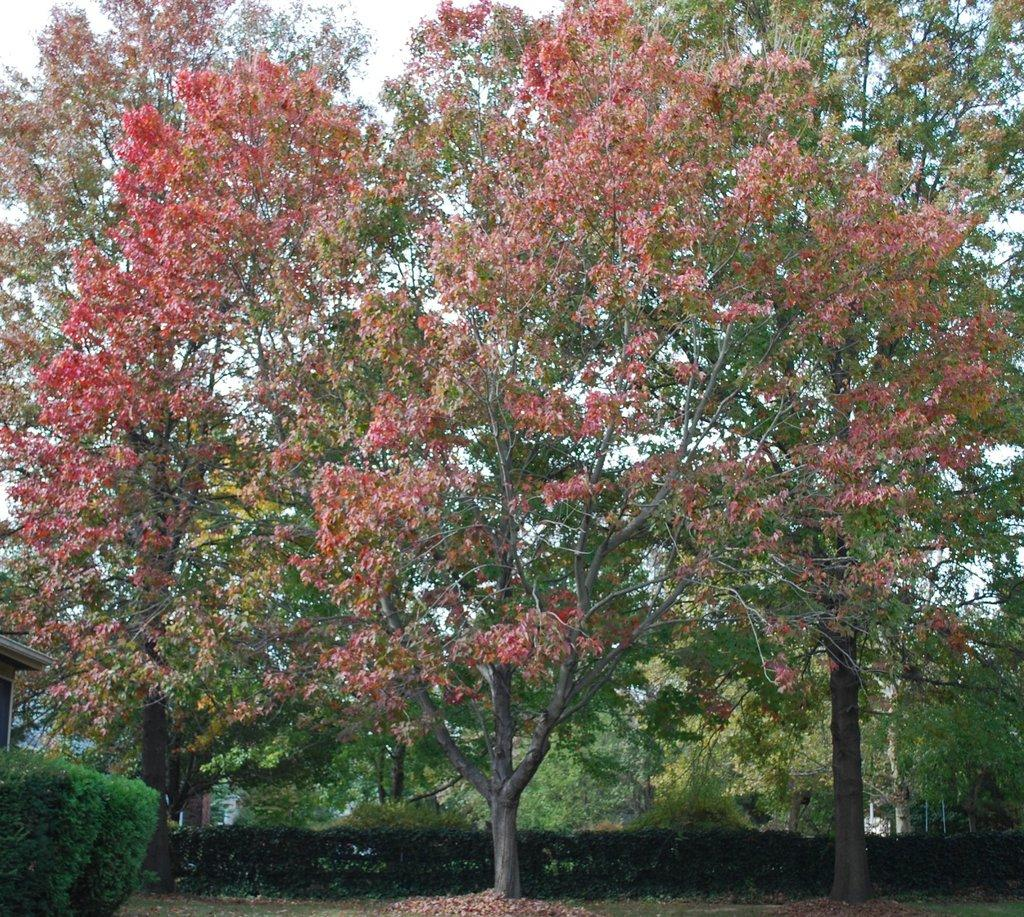What type of vegetation can be seen in the image? There are trees, plants, and bushes in the image. Are there any flowers visible in the image? Yes, flowers are present on the trees in the image. What type of cap can be seen on the loaf in the image? There is no cap or loaf present in the image; it features trees, plants, bushes, and flowers. 